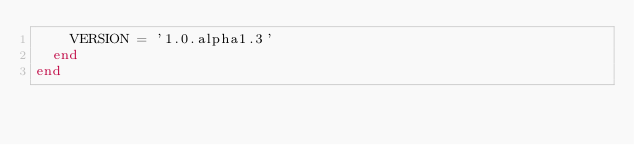Convert code to text. <code><loc_0><loc_0><loc_500><loc_500><_Ruby_>    VERSION = '1.0.alpha1.3'
  end
end
</code> 